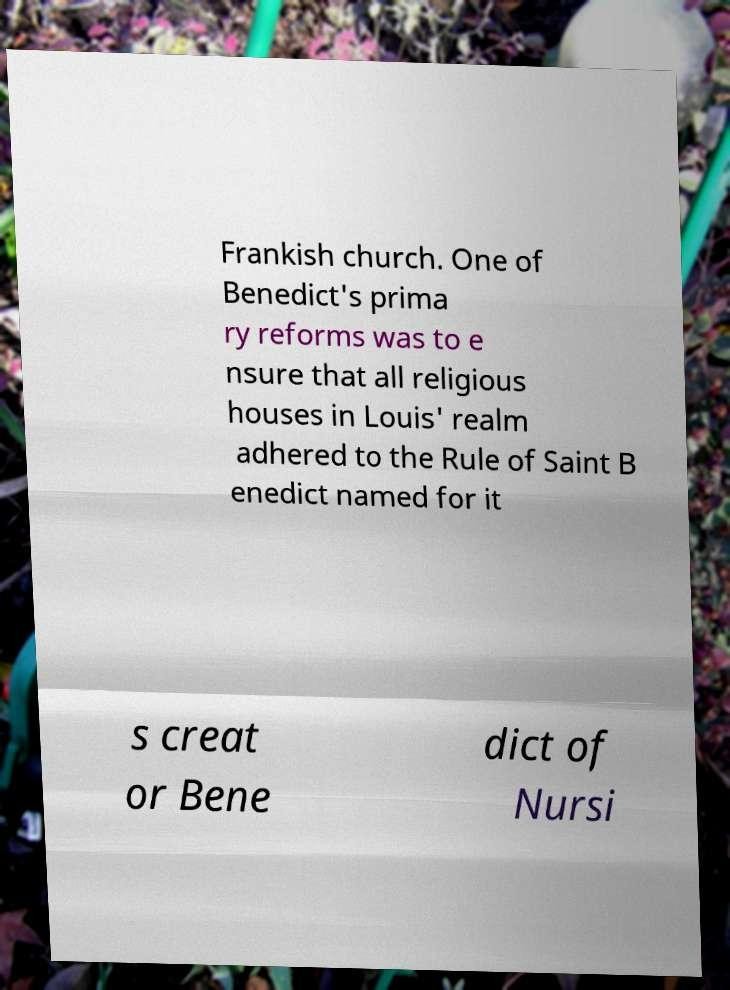Please identify and transcribe the text found in this image. Frankish church. One of Benedict's prima ry reforms was to e nsure that all religious houses in Louis' realm adhered to the Rule of Saint B enedict named for it s creat or Bene dict of Nursi 